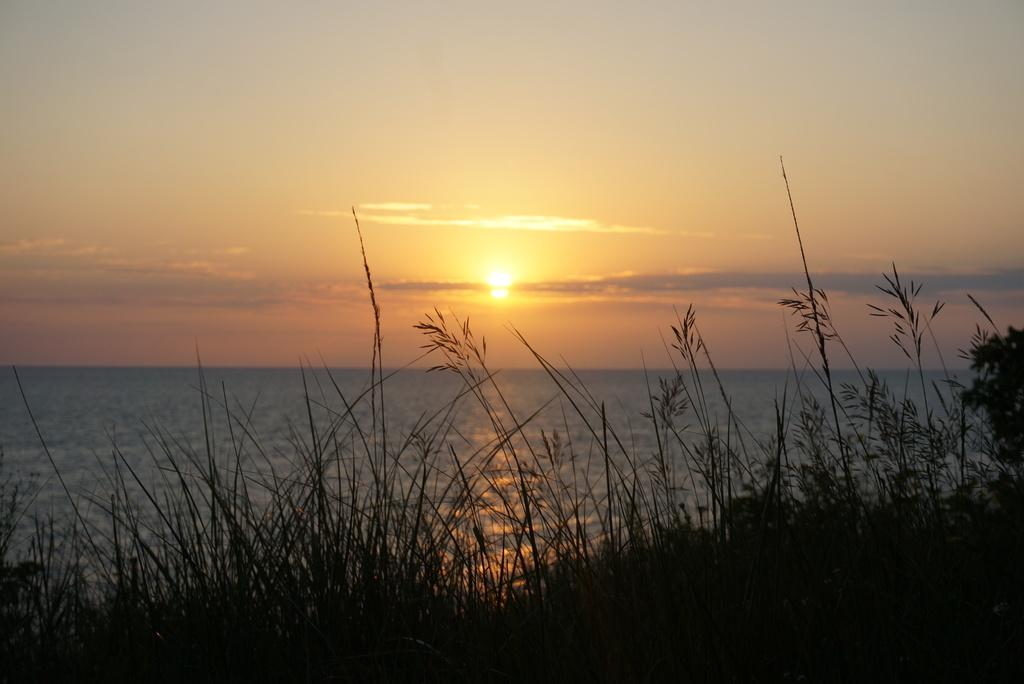What type of living organisms can be seen in the image? Plants can be seen in the image. Where are the plants located in relation to the image? The plants are in the foreground of the image. What else can be seen in the background of the image? Water and the sky can be seen in the background of the image. Can the sun be seen in the image? Yes, the sun is observable in the image. What type of attention is the governor seeking in the image? There is no governor present in the image, so it is not possible to determine what type of attention they might be seeking. 